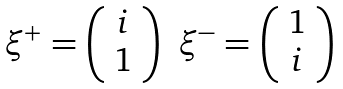Convert formula to latex. <formula><loc_0><loc_0><loc_500><loc_500>\begin{array} { c c } \xi ^ { + } = \left ( \begin{array} { c } i \\ 1 \end{array} \right ) & \xi ^ { - } = \left ( \begin{array} { c } 1 \\ i \end{array} \right ) \end{array}</formula> 